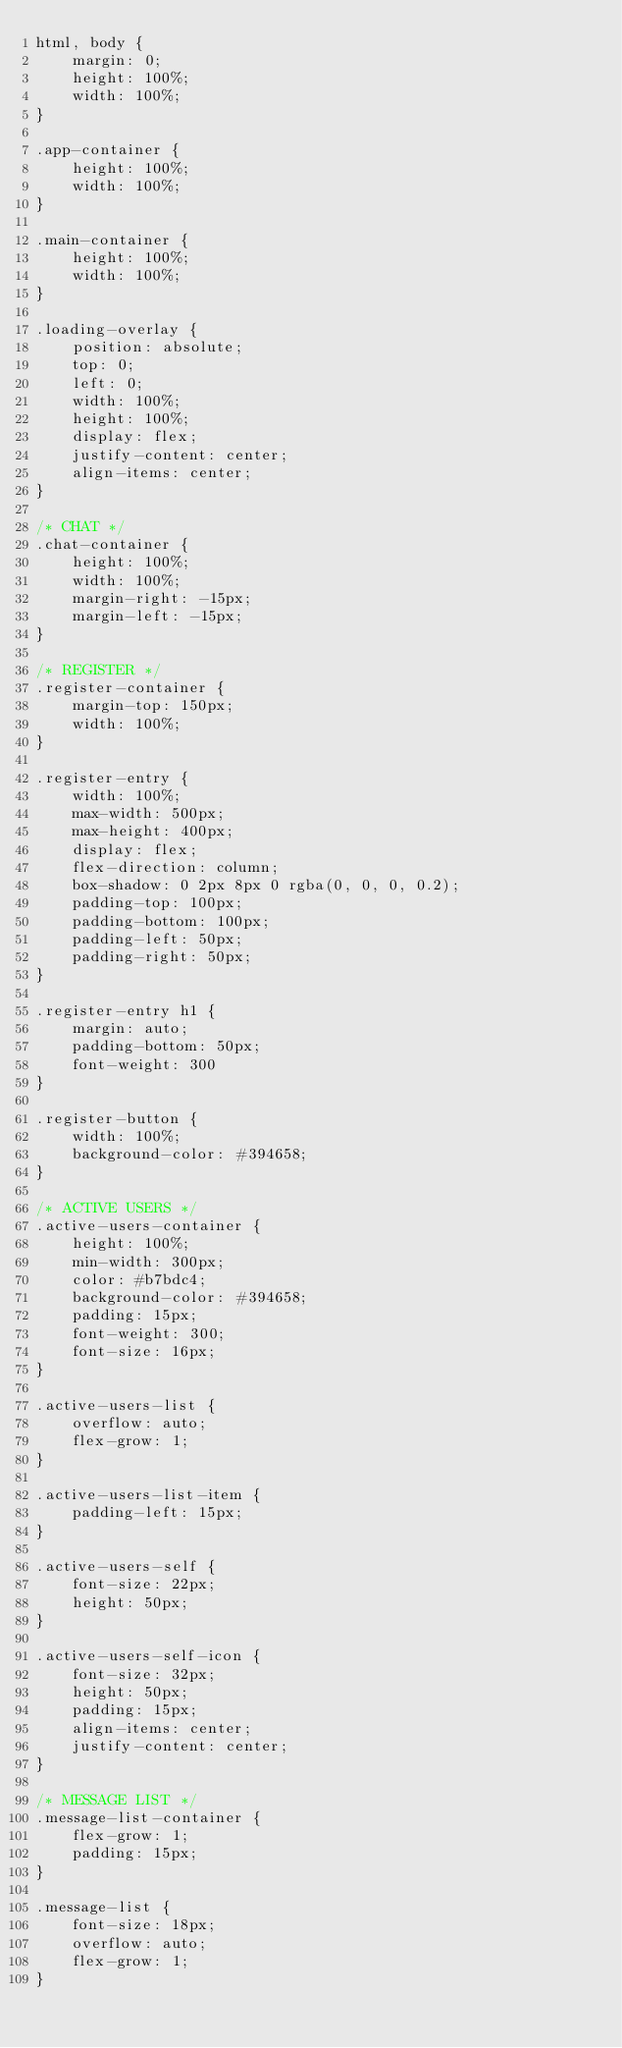<code> <loc_0><loc_0><loc_500><loc_500><_CSS_>html, body {
    margin: 0;
    height: 100%;
    width: 100%;
}

.app-container {
    height: 100%;
    width: 100%;
}

.main-container {
    height: 100%;
    width: 100%;
}

.loading-overlay {
    position: absolute;
    top: 0;
    left: 0;
    width: 100%;
    height: 100%;
    display: flex;
    justify-content: center;
    align-items: center;
}

/* CHAT */
.chat-container {
    height: 100%;
    width: 100%;
    margin-right: -15px;
    margin-left: -15px;
}

/* REGISTER */
.register-container {
    margin-top: 150px;
    width: 100%;
}

.register-entry {
    width: 100%;
    max-width: 500px;
    max-height: 400px;
    display: flex;
    flex-direction: column;
    box-shadow: 0 2px 8px 0 rgba(0, 0, 0, 0.2);
    padding-top: 100px;
    padding-bottom: 100px;
    padding-left: 50px;
    padding-right: 50px;
}

.register-entry h1 {
    margin: auto;
    padding-bottom: 50px;
    font-weight: 300
}

.register-button {
    width: 100%;
    background-color: #394658;
}

/* ACTIVE USERS */
.active-users-container {
    height: 100%;
    min-width: 300px;
    color: #b7bdc4;
    background-color: #394658;
    padding: 15px;
    font-weight: 300;
    font-size: 16px;
}

.active-users-list {
    overflow: auto;
    flex-grow: 1;
}

.active-users-list-item {
    padding-left: 15px;
}

.active-users-self {
    font-size: 22px;
    height: 50px;
}

.active-users-self-icon {
    font-size: 32px;
    height: 50px;
    padding: 15px;
    align-items: center;
    justify-content: center;
}

/* MESSAGE LIST */
.message-list-container {
    flex-grow: 1;
    padding: 15px;
}

.message-list {
    font-size: 18px;
    overflow: auto;
    flex-grow: 1;
}</code> 